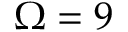Convert formula to latex. <formula><loc_0><loc_0><loc_500><loc_500>\Omega = 9</formula> 